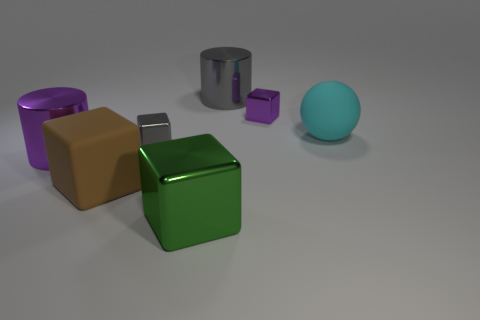There is a cylinder to the left of the brown cube in front of the rubber thing that is behind the brown matte block; what is its size?
Your response must be concise. Large. There is a large cylinder in front of the small shiny thing right of the large gray cylinder; what color is it?
Make the answer very short. Purple. What is the material of the other large object that is the same shape as the large gray object?
Your answer should be very brief. Metal. Is there anything else that has the same material as the large purple object?
Offer a terse response. Yes. Are there any big cyan matte spheres to the right of the green shiny cube?
Your answer should be very brief. Yes. What number of large blocks are there?
Offer a very short reply. 2. What number of cubes are right of the small gray object behind the green metal cube?
Your answer should be compact. 2. Does the sphere have the same color as the tiny cube right of the green object?
Make the answer very short. No. How many big green shiny objects are the same shape as the brown thing?
Ensure brevity in your answer.  1. There is a gray object in front of the cyan ball; what material is it?
Your answer should be compact. Metal. 